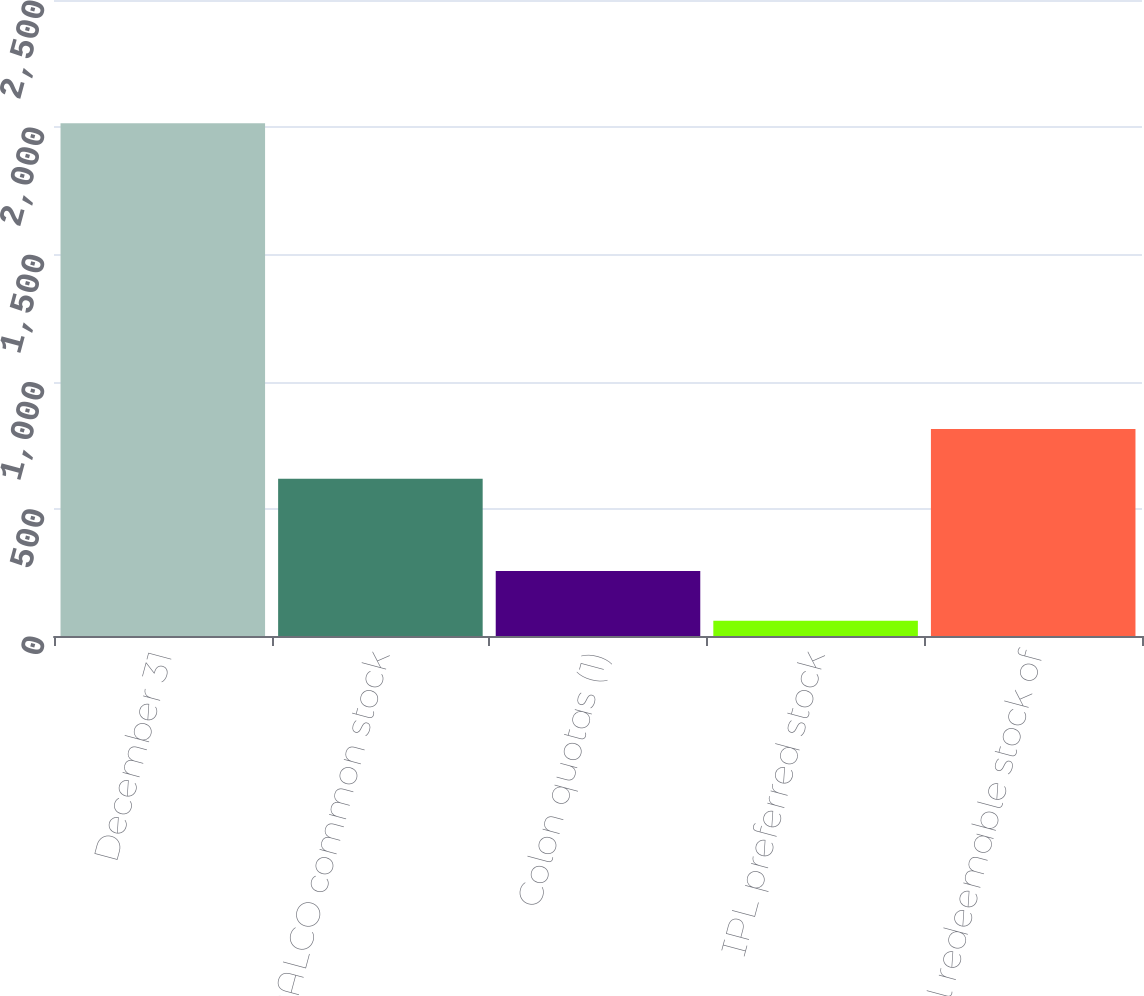Convert chart. <chart><loc_0><loc_0><loc_500><loc_500><bar_chart><fcel>December 31<fcel>IPALCO common stock<fcel>Colon quotas (1)<fcel>IPL preferred stock<fcel>Total redeemable stock of<nl><fcel>2016<fcel>618<fcel>255.6<fcel>60<fcel>813.6<nl></chart> 